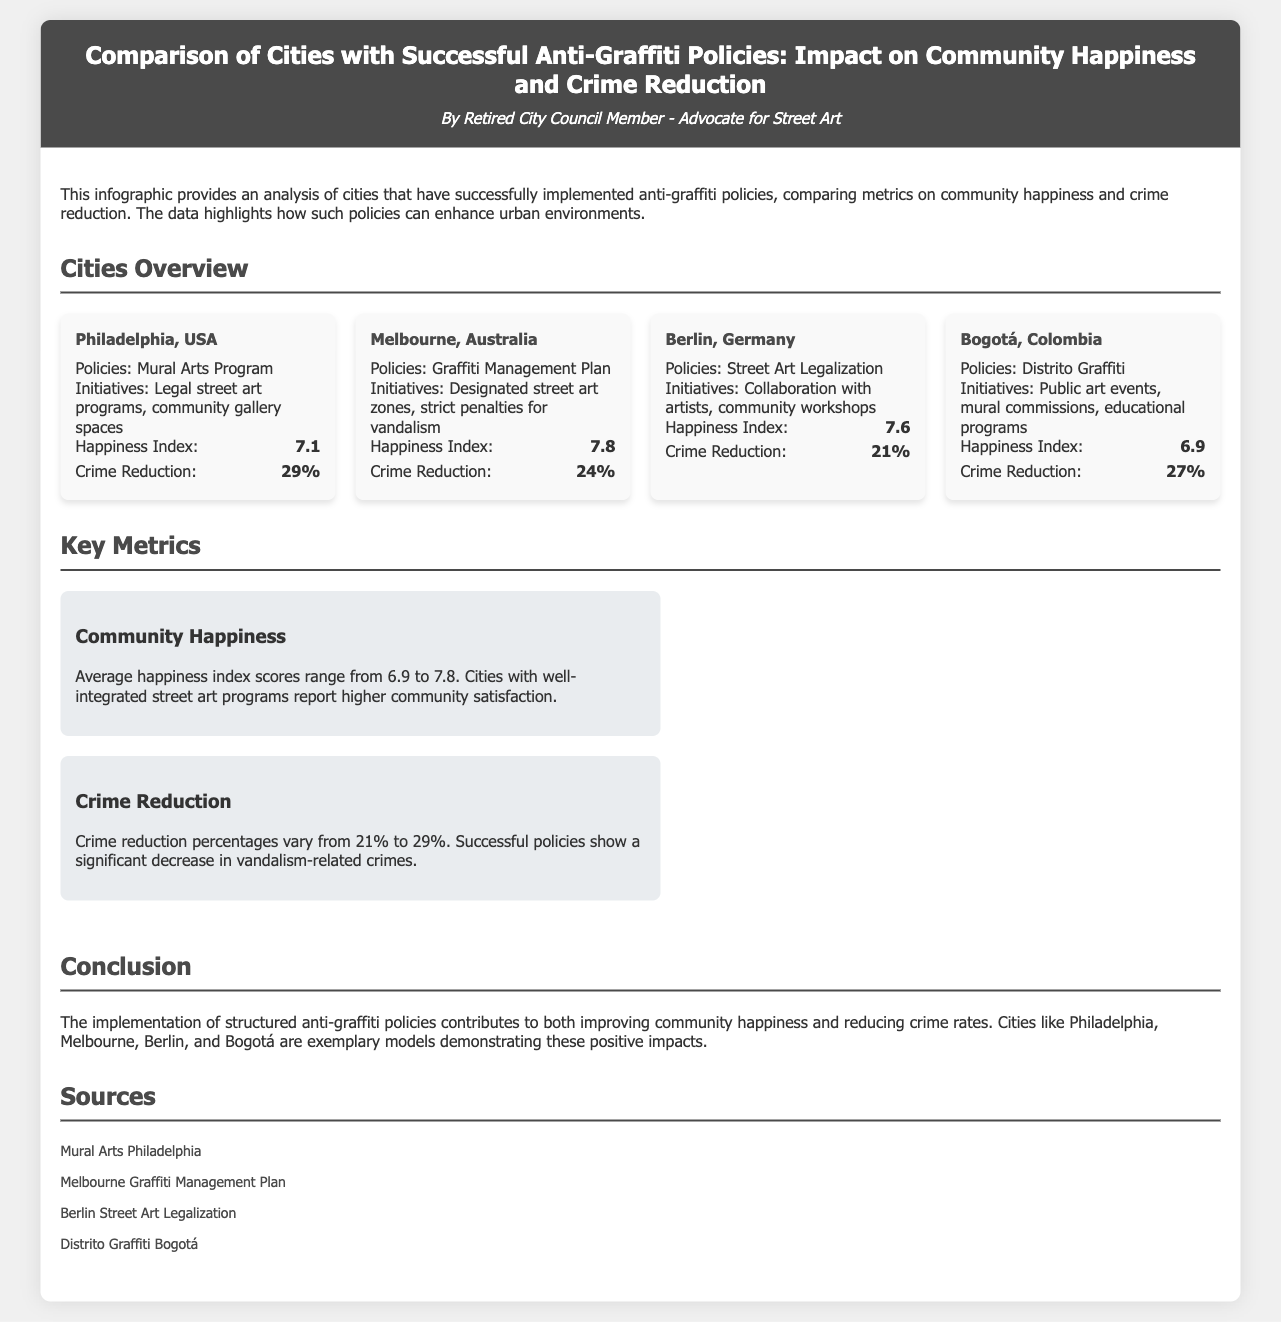What is the happiness index of Melbourne? Melbourne's happiness index is specified in the city overview section of the document.
Answer: 7.8 Which city has a crime reduction percentage of 21%? The crime reduction percentage for each city is provided in the metric section of the city overview.
Answer: Berlin, Germany What is the name of the initiative in Bogotá? The initiative in Bogotá is stated under the city overview and includes details about their public art events.
Answer: Distrito Graffiti Which city implemented the Mural Arts Program? The Mural Arts Program is one of the policies listed for a specific city in the document.
Answer: Philadelphia, USA What is the average happiness index score range reported in the key metrics section? The key metrics section summarizes the community happiness scores provided in the city overview.
Answer: 6.9 to 7.8 Which city shows the highest crime reduction percentage? The crime reduction percentages for each city allow us to directly compare and find the highest value.
Answer: Philadelphia, USA How many cities are compared in the document? The document provides an overview of the cities mentioned, clearly listing each one.
Answer: Four What type of policies does Melbourne use to manage graffiti? The types of policies used in each city are outlined in the city overview section.
Answer: Graffiti Management Plan What is the concluding statement about the impact of anti-graffiti policies? The conclusion summarizes the overall findings discussed throughout the document.
Answer: Improves community happiness and reduces crime rates 